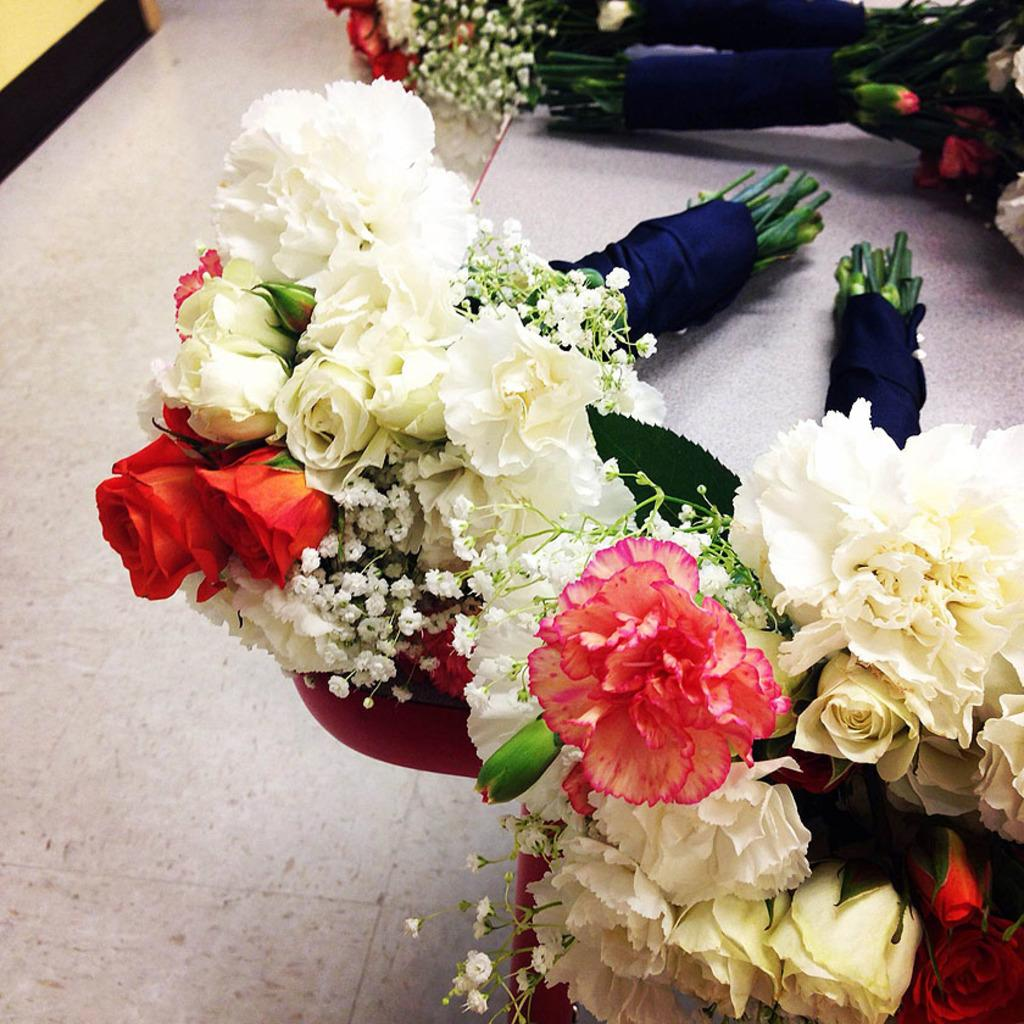What is present in the image? There are bunches of flowers in the image. Where are the flowers located? The flowers are on a table. What type of bait is being used to attract the dogs in the image? There are no dogs or bait present in the image; it only features bunches of flowers on a table. 